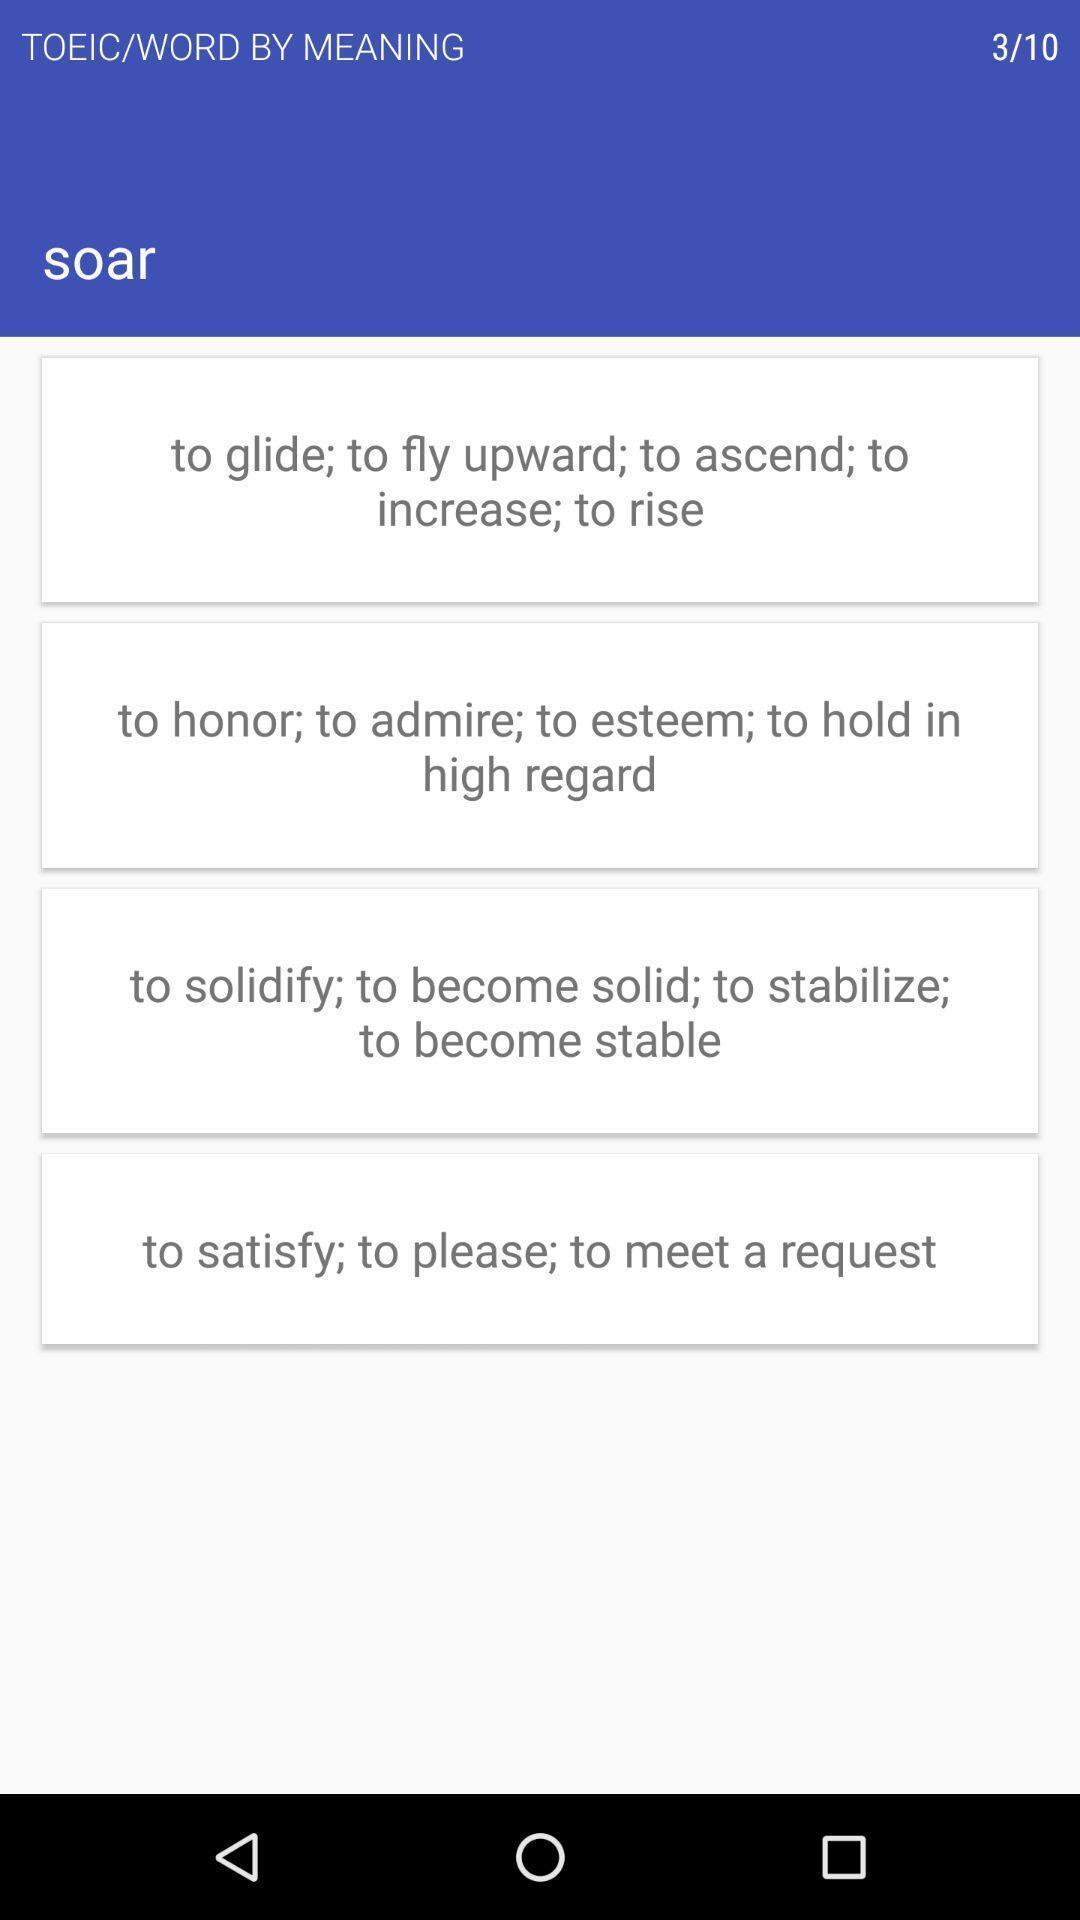Tell me about the visual elements in this screen capture. Window displaying a vocabulary app. 